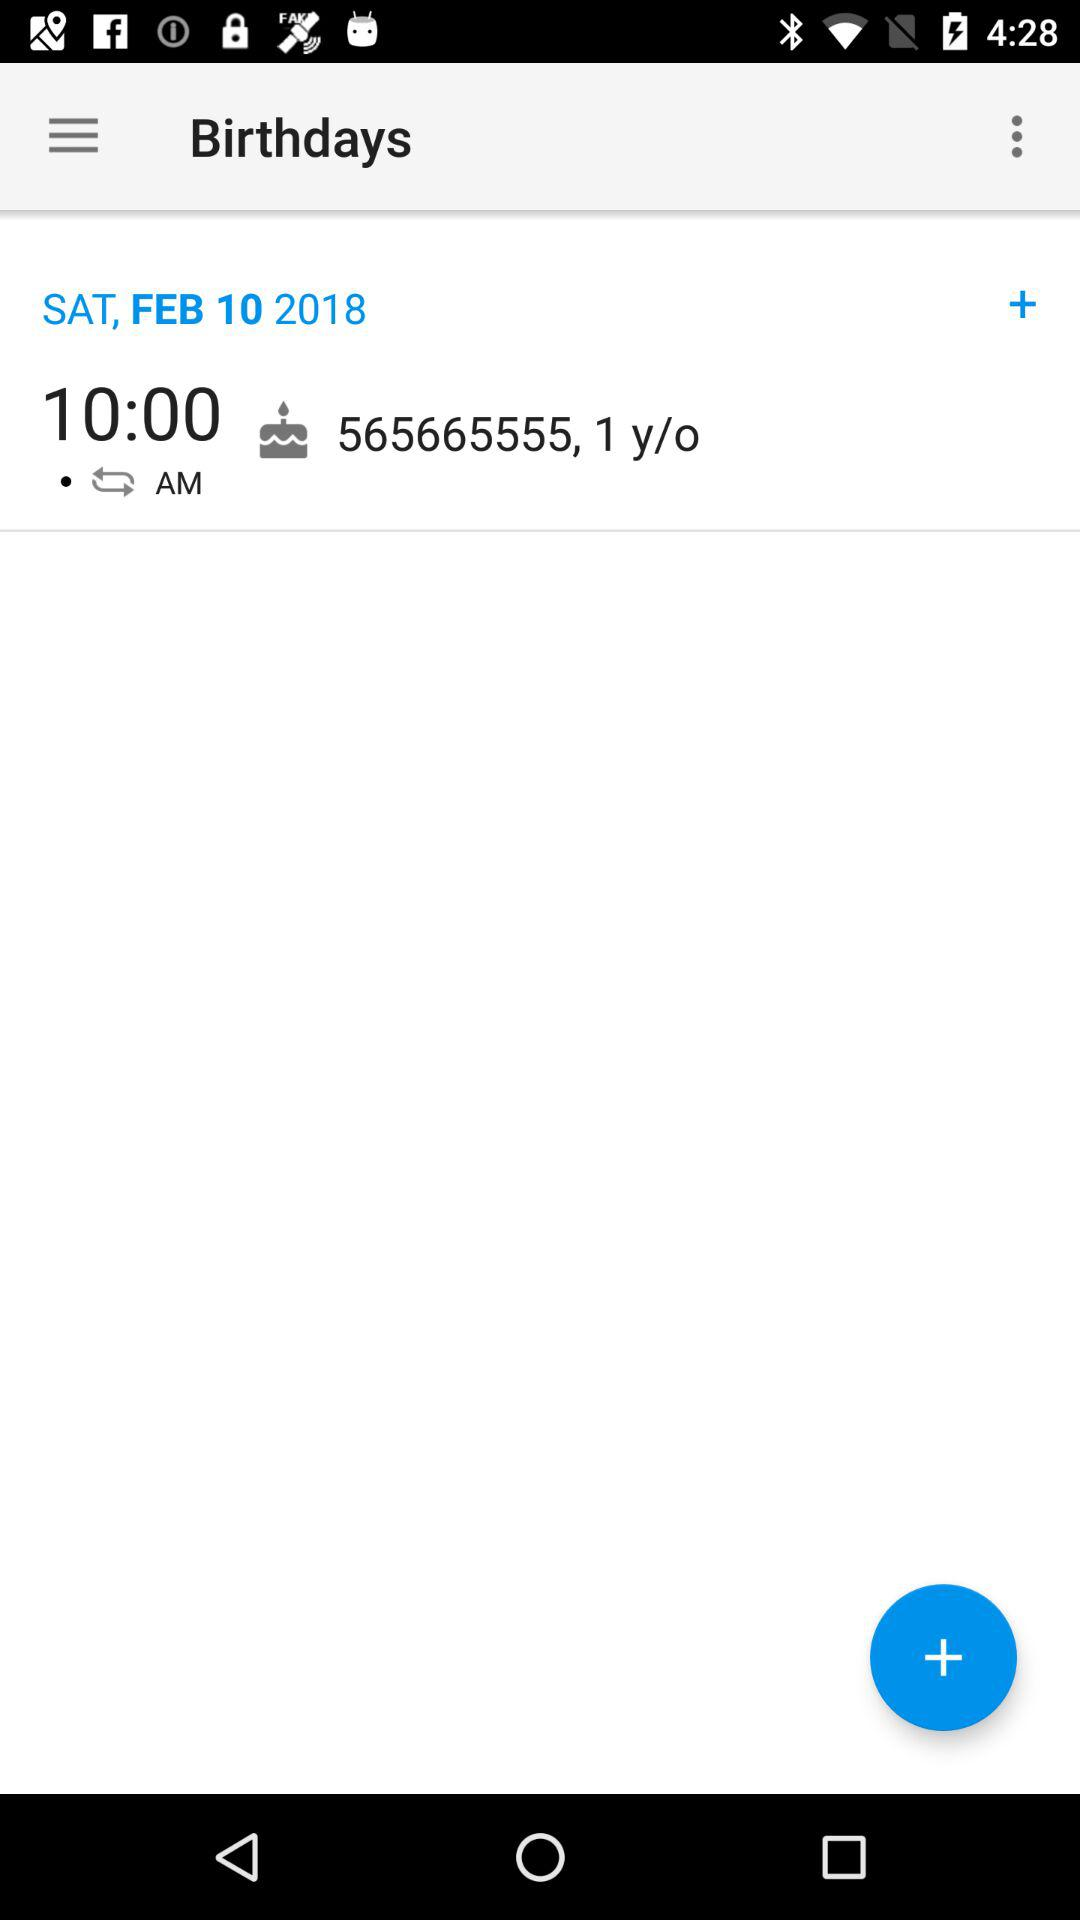How many years old is the birthday person?
Answer the question using a single word or phrase. 1 